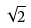Convert formula to latex. <formula><loc_0><loc_0><loc_500><loc_500>\sqrt { 2 }</formula> 